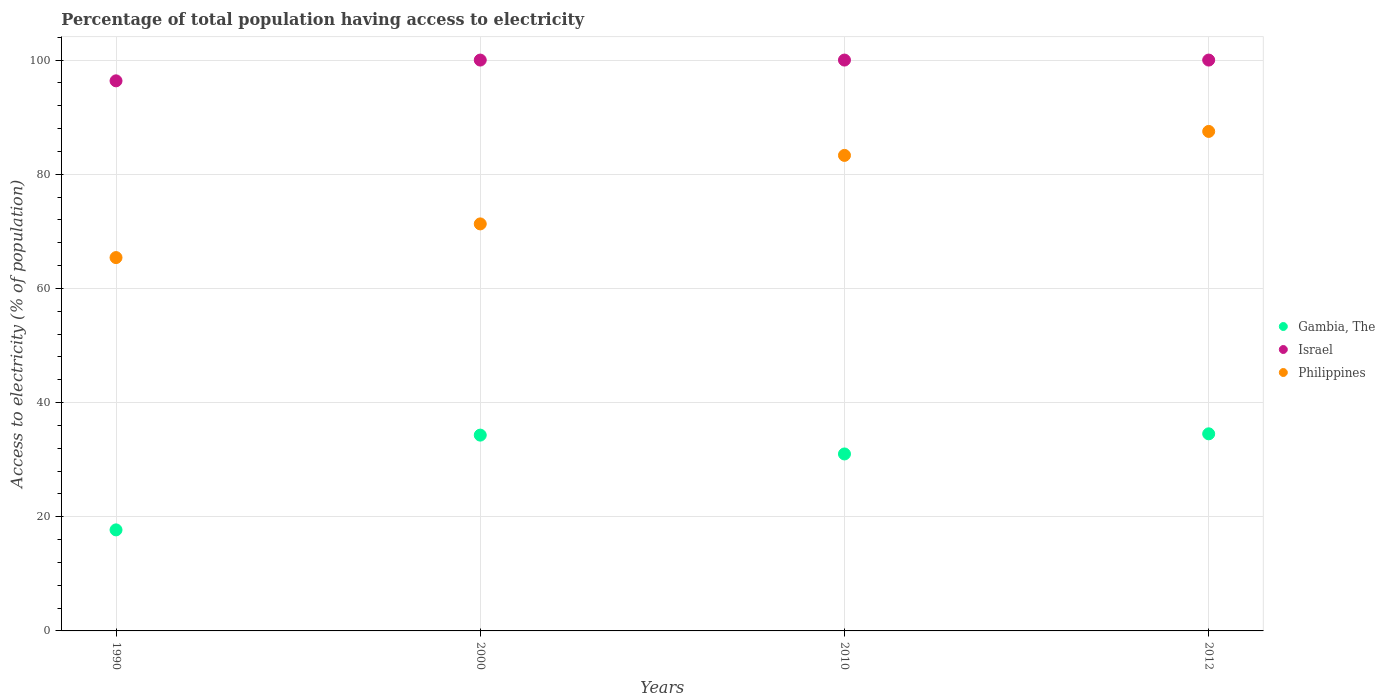How many different coloured dotlines are there?
Keep it short and to the point. 3. What is the percentage of population that have access to electricity in Philippines in 2010?
Provide a succinct answer. 83.3. Across all years, what is the maximum percentage of population that have access to electricity in Gambia, The?
Keep it short and to the point. 34.53. Across all years, what is the minimum percentage of population that have access to electricity in Philippines?
Ensure brevity in your answer.  65.4. What is the total percentage of population that have access to electricity in Gambia, The in the graph?
Offer a very short reply. 117.53. What is the difference between the percentage of population that have access to electricity in Philippines in 2010 and that in 2012?
Your answer should be compact. -4.2. What is the average percentage of population that have access to electricity in Philippines per year?
Give a very brief answer. 76.88. In the year 2012, what is the difference between the percentage of population that have access to electricity in Israel and percentage of population that have access to electricity in Gambia, The?
Your answer should be very brief. 65.47. What is the ratio of the percentage of population that have access to electricity in Gambia, The in 2010 to that in 2012?
Keep it short and to the point. 0.9. Is the percentage of population that have access to electricity in Israel in 1990 less than that in 2010?
Your response must be concise. Yes. Is the difference between the percentage of population that have access to electricity in Israel in 1990 and 2012 greater than the difference between the percentage of population that have access to electricity in Gambia, The in 1990 and 2012?
Ensure brevity in your answer.  Yes. What is the difference between the highest and the lowest percentage of population that have access to electricity in Philippines?
Keep it short and to the point. 22.1. Is the sum of the percentage of population that have access to electricity in Israel in 1990 and 2012 greater than the maximum percentage of population that have access to electricity in Philippines across all years?
Your response must be concise. Yes. Does the percentage of population that have access to electricity in Israel monotonically increase over the years?
Give a very brief answer. No. Is the percentage of population that have access to electricity in Gambia, The strictly greater than the percentage of population that have access to electricity in Philippines over the years?
Provide a succinct answer. No. Is the percentage of population that have access to electricity in Gambia, The strictly less than the percentage of population that have access to electricity in Israel over the years?
Make the answer very short. Yes. How many dotlines are there?
Keep it short and to the point. 3. Does the graph contain any zero values?
Provide a succinct answer. No. Does the graph contain grids?
Provide a short and direct response. Yes. Where does the legend appear in the graph?
Your answer should be very brief. Center right. How are the legend labels stacked?
Offer a very short reply. Vertical. What is the title of the graph?
Offer a terse response. Percentage of total population having access to electricity. What is the label or title of the Y-axis?
Your response must be concise. Access to electricity (% of population). What is the Access to electricity (% of population) in Israel in 1990?
Ensure brevity in your answer.  96.36. What is the Access to electricity (% of population) in Philippines in 1990?
Provide a succinct answer. 65.4. What is the Access to electricity (% of population) of Gambia, The in 2000?
Your response must be concise. 34.3. What is the Access to electricity (% of population) in Israel in 2000?
Keep it short and to the point. 100. What is the Access to electricity (% of population) in Philippines in 2000?
Ensure brevity in your answer.  71.3. What is the Access to electricity (% of population) in Philippines in 2010?
Provide a succinct answer. 83.3. What is the Access to electricity (% of population) in Gambia, The in 2012?
Your response must be concise. 34.53. What is the Access to electricity (% of population) in Philippines in 2012?
Provide a succinct answer. 87.5. Across all years, what is the maximum Access to electricity (% of population) in Gambia, The?
Provide a succinct answer. 34.53. Across all years, what is the maximum Access to electricity (% of population) in Philippines?
Your response must be concise. 87.5. Across all years, what is the minimum Access to electricity (% of population) in Israel?
Offer a very short reply. 96.36. Across all years, what is the minimum Access to electricity (% of population) in Philippines?
Your response must be concise. 65.4. What is the total Access to electricity (% of population) in Gambia, The in the graph?
Your answer should be very brief. 117.53. What is the total Access to electricity (% of population) of Israel in the graph?
Your answer should be compact. 396.36. What is the total Access to electricity (% of population) of Philippines in the graph?
Provide a short and direct response. 307.5. What is the difference between the Access to electricity (% of population) of Gambia, The in 1990 and that in 2000?
Your answer should be very brief. -16.6. What is the difference between the Access to electricity (% of population) in Israel in 1990 and that in 2000?
Provide a succinct answer. -3.64. What is the difference between the Access to electricity (% of population) of Philippines in 1990 and that in 2000?
Ensure brevity in your answer.  -5.9. What is the difference between the Access to electricity (% of population) in Gambia, The in 1990 and that in 2010?
Your answer should be compact. -13.3. What is the difference between the Access to electricity (% of population) in Israel in 1990 and that in 2010?
Your answer should be compact. -3.64. What is the difference between the Access to electricity (% of population) of Philippines in 1990 and that in 2010?
Provide a short and direct response. -17.9. What is the difference between the Access to electricity (% of population) in Gambia, The in 1990 and that in 2012?
Make the answer very short. -16.83. What is the difference between the Access to electricity (% of population) in Israel in 1990 and that in 2012?
Offer a terse response. -3.64. What is the difference between the Access to electricity (% of population) of Philippines in 1990 and that in 2012?
Provide a short and direct response. -22.1. What is the difference between the Access to electricity (% of population) in Gambia, The in 2000 and that in 2010?
Keep it short and to the point. 3.3. What is the difference between the Access to electricity (% of population) of Israel in 2000 and that in 2010?
Offer a very short reply. 0. What is the difference between the Access to electricity (% of population) in Philippines in 2000 and that in 2010?
Provide a succinct answer. -12. What is the difference between the Access to electricity (% of population) in Gambia, The in 2000 and that in 2012?
Offer a very short reply. -0.23. What is the difference between the Access to electricity (% of population) in Philippines in 2000 and that in 2012?
Provide a short and direct response. -16.2. What is the difference between the Access to electricity (% of population) of Gambia, The in 2010 and that in 2012?
Give a very brief answer. -3.53. What is the difference between the Access to electricity (% of population) in Israel in 2010 and that in 2012?
Offer a terse response. 0. What is the difference between the Access to electricity (% of population) of Philippines in 2010 and that in 2012?
Provide a succinct answer. -4.2. What is the difference between the Access to electricity (% of population) in Gambia, The in 1990 and the Access to electricity (% of population) in Israel in 2000?
Ensure brevity in your answer.  -82.3. What is the difference between the Access to electricity (% of population) in Gambia, The in 1990 and the Access to electricity (% of population) in Philippines in 2000?
Provide a succinct answer. -53.6. What is the difference between the Access to electricity (% of population) of Israel in 1990 and the Access to electricity (% of population) of Philippines in 2000?
Provide a short and direct response. 25.06. What is the difference between the Access to electricity (% of population) of Gambia, The in 1990 and the Access to electricity (% of population) of Israel in 2010?
Offer a very short reply. -82.3. What is the difference between the Access to electricity (% of population) in Gambia, The in 1990 and the Access to electricity (% of population) in Philippines in 2010?
Make the answer very short. -65.6. What is the difference between the Access to electricity (% of population) in Israel in 1990 and the Access to electricity (% of population) in Philippines in 2010?
Offer a terse response. 13.06. What is the difference between the Access to electricity (% of population) of Gambia, The in 1990 and the Access to electricity (% of population) of Israel in 2012?
Offer a very short reply. -82.3. What is the difference between the Access to electricity (% of population) of Gambia, The in 1990 and the Access to electricity (% of population) of Philippines in 2012?
Make the answer very short. -69.8. What is the difference between the Access to electricity (% of population) in Israel in 1990 and the Access to electricity (% of population) in Philippines in 2012?
Make the answer very short. 8.86. What is the difference between the Access to electricity (% of population) in Gambia, The in 2000 and the Access to electricity (% of population) in Israel in 2010?
Offer a very short reply. -65.7. What is the difference between the Access to electricity (% of population) in Gambia, The in 2000 and the Access to electricity (% of population) in Philippines in 2010?
Your answer should be compact. -49. What is the difference between the Access to electricity (% of population) of Israel in 2000 and the Access to electricity (% of population) of Philippines in 2010?
Offer a terse response. 16.7. What is the difference between the Access to electricity (% of population) of Gambia, The in 2000 and the Access to electricity (% of population) of Israel in 2012?
Your response must be concise. -65.7. What is the difference between the Access to electricity (% of population) of Gambia, The in 2000 and the Access to electricity (% of population) of Philippines in 2012?
Give a very brief answer. -53.2. What is the difference between the Access to electricity (% of population) of Gambia, The in 2010 and the Access to electricity (% of population) of Israel in 2012?
Your answer should be very brief. -69. What is the difference between the Access to electricity (% of population) of Gambia, The in 2010 and the Access to electricity (% of population) of Philippines in 2012?
Keep it short and to the point. -56.5. What is the difference between the Access to electricity (% of population) of Israel in 2010 and the Access to electricity (% of population) of Philippines in 2012?
Give a very brief answer. 12.5. What is the average Access to electricity (% of population) in Gambia, The per year?
Your answer should be very brief. 29.38. What is the average Access to electricity (% of population) in Israel per year?
Your answer should be compact. 99.09. What is the average Access to electricity (% of population) in Philippines per year?
Offer a very short reply. 76.88. In the year 1990, what is the difference between the Access to electricity (% of population) in Gambia, The and Access to electricity (% of population) in Israel?
Make the answer very short. -78.66. In the year 1990, what is the difference between the Access to electricity (% of population) in Gambia, The and Access to electricity (% of population) in Philippines?
Offer a terse response. -47.7. In the year 1990, what is the difference between the Access to electricity (% of population) of Israel and Access to electricity (% of population) of Philippines?
Your answer should be compact. 30.96. In the year 2000, what is the difference between the Access to electricity (% of population) in Gambia, The and Access to electricity (% of population) in Israel?
Make the answer very short. -65.7. In the year 2000, what is the difference between the Access to electricity (% of population) in Gambia, The and Access to electricity (% of population) in Philippines?
Offer a very short reply. -37. In the year 2000, what is the difference between the Access to electricity (% of population) in Israel and Access to electricity (% of population) in Philippines?
Your response must be concise. 28.7. In the year 2010, what is the difference between the Access to electricity (% of population) in Gambia, The and Access to electricity (% of population) in Israel?
Offer a very short reply. -69. In the year 2010, what is the difference between the Access to electricity (% of population) of Gambia, The and Access to electricity (% of population) of Philippines?
Offer a very short reply. -52.3. In the year 2012, what is the difference between the Access to electricity (% of population) in Gambia, The and Access to electricity (% of population) in Israel?
Your answer should be very brief. -65.47. In the year 2012, what is the difference between the Access to electricity (% of population) in Gambia, The and Access to electricity (% of population) in Philippines?
Offer a very short reply. -52.97. In the year 2012, what is the difference between the Access to electricity (% of population) of Israel and Access to electricity (% of population) of Philippines?
Give a very brief answer. 12.5. What is the ratio of the Access to electricity (% of population) in Gambia, The in 1990 to that in 2000?
Your answer should be very brief. 0.52. What is the ratio of the Access to electricity (% of population) of Israel in 1990 to that in 2000?
Your answer should be compact. 0.96. What is the ratio of the Access to electricity (% of population) in Philippines in 1990 to that in 2000?
Give a very brief answer. 0.92. What is the ratio of the Access to electricity (% of population) in Gambia, The in 1990 to that in 2010?
Provide a succinct answer. 0.57. What is the ratio of the Access to electricity (% of population) of Israel in 1990 to that in 2010?
Make the answer very short. 0.96. What is the ratio of the Access to electricity (% of population) of Philippines in 1990 to that in 2010?
Provide a short and direct response. 0.79. What is the ratio of the Access to electricity (% of population) in Gambia, The in 1990 to that in 2012?
Ensure brevity in your answer.  0.51. What is the ratio of the Access to electricity (% of population) in Israel in 1990 to that in 2012?
Your response must be concise. 0.96. What is the ratio of the Access to electricity (% of population) in Philippines in 1990 to that in 2012?
Provide a short and direct response. 0.75. What is the ratio of the Access to electricity (% of population) in Gambia, The in 2000 to that in 2010?
Your answer should be compact. 1.11. What is the ratio of the Access to electricity (% of population) of Philippines in 2000 to that in 2010?
Your answer should be compact. 0.86. What is the ratio of the Access to electricity (% of population) in Gambia, The in 2000 to that in 2012?
Make the answer very short. 0.99. What is the ratio of the Access to electricity (% of population) of Israel in 2000 to that in 2012?
Keep it short and to the point. 1. What is the ratio of the Access to electricity (% of population) in Philippines in 2000 to that in 2012?
Offer a very short reply. 0.81. What is the ratio of the Access to electricity (% of population) in Gambia, The in 2010 to that in 2012?
Ensure brevity in your answer.  0.9. What is the ratio of the Access to electricity (% of population) in Israel in 2010 to that in 2012?
Offer a terse response. 1. What is the difference between the highest and the second highest Access to electricity (% of population) of Gambia, The?
Provide a short and direct response. 0.23. What is the difference between the highest and the lowest Access to electricity (% of population) in Gambia, The?
Your answer should be compact. 16.83. What is the difference between the highest and the lowest Access to electricity (% of population) of Israel?
Keep it short and to the point. 3.64. What is the difference between the highest and the lowest Access to electricity (% of population) in Philippines?
Your answer should be very brief. 22.1. 